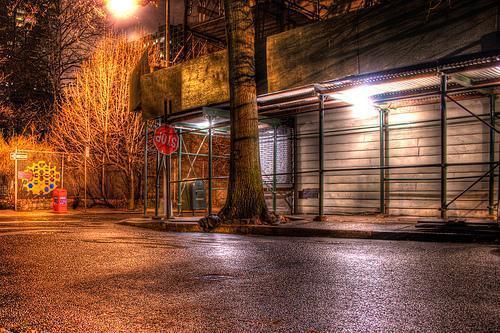How many people are there?
Give a very brief answer. 0. 